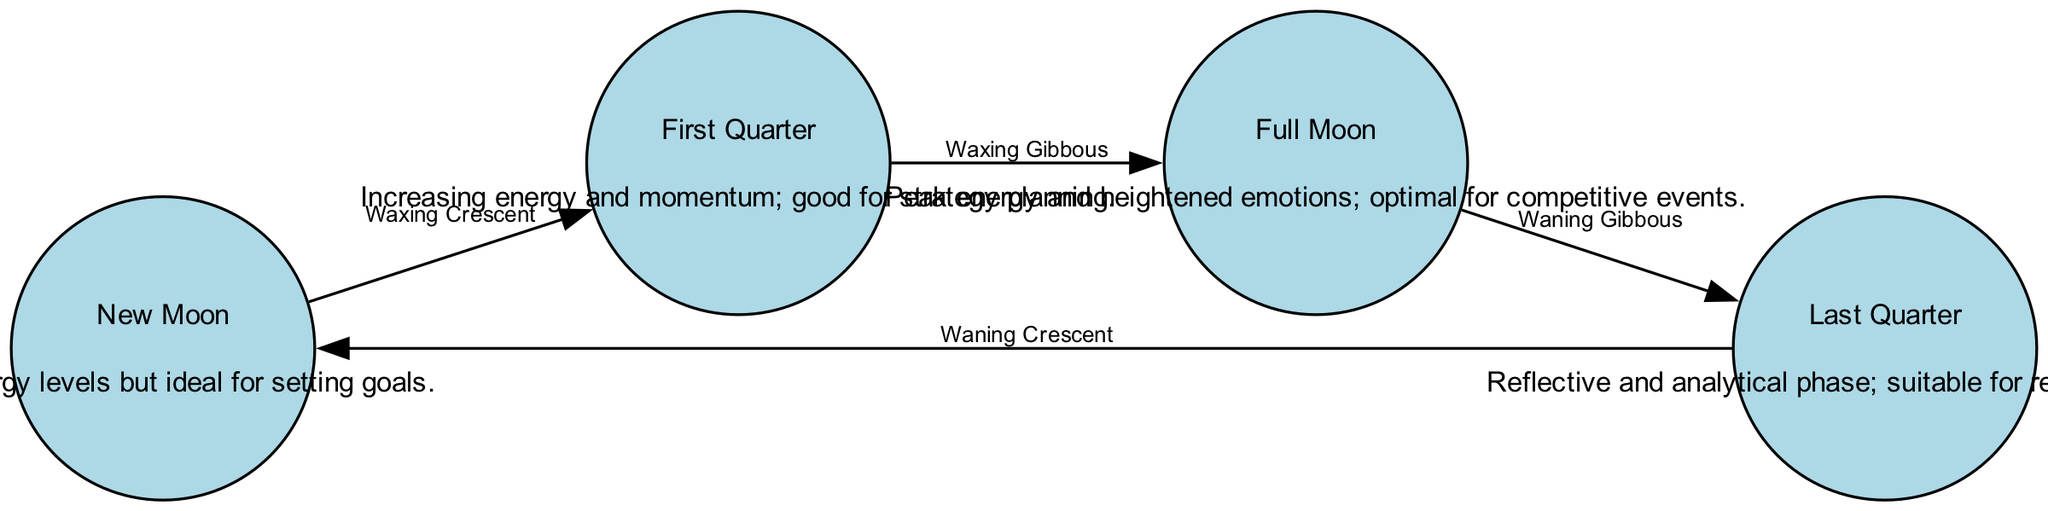What is the label of the node representing the peak energy phase? The peak energy phase is represented by the node labeled "Full Moon." This can be found by looking for the node with the description mentioning "peak energy."
Answer: Full Moon How many phases of the Moon are represented in this diagram? The diagram contains four nodes, each corresponding to a different phase of the Moon. By counting the nodes listed, we find that there are four distinct phases.
Answer: 4 What phase comes after the First Quarter? The node directly connected by the edge labeled "Waxing Gibbous" indicates that the phase coming after the First Quarter is the Full Moon. This can be determined by tracing the directed edge leading from First Quarter to Full Moon.
Answer: Full Moon What is the relationship between Full Moon and Last Quarter? The relationship is indicated by the edge labeled "Waning Gibbous," which directs from Full Moon to Last Quarter. This tells us about the transition from the Full Moon phase to the Last Quarter phase.
Answer: Waning Gibbous Which phase is suitable for review and recovery? The description under the Last Quarter node mentions it is reflective and analytical, making it suitable for review and recovery. This conclusion is drawn from the information provided in the node's description.
Answer: Last Quarter What is the energy state in the New Moon phase? The description for the New Moon node states it has low energy levels. Thus, to answer the question, we refer directly to the information in the New Moon's description.
Answer: Low energy levels In what phase is strategy planning considered good? According to the description of the First Quarter phase, it indicates that this is when strategy planning is good. This can be found by looking at the text associated with that specific node.
Answer: First Quarter What is indicated by the edge labeled "Waning Crescent"? The edge labeled "Waning Crescent" connects the Last Quarter back to the New Moon, indicating that this edge represents the transition from Last Quarter to New Moon. Understanding this edge's direction helps clarify the flow of phases.
Answer: Transition to New Moon 